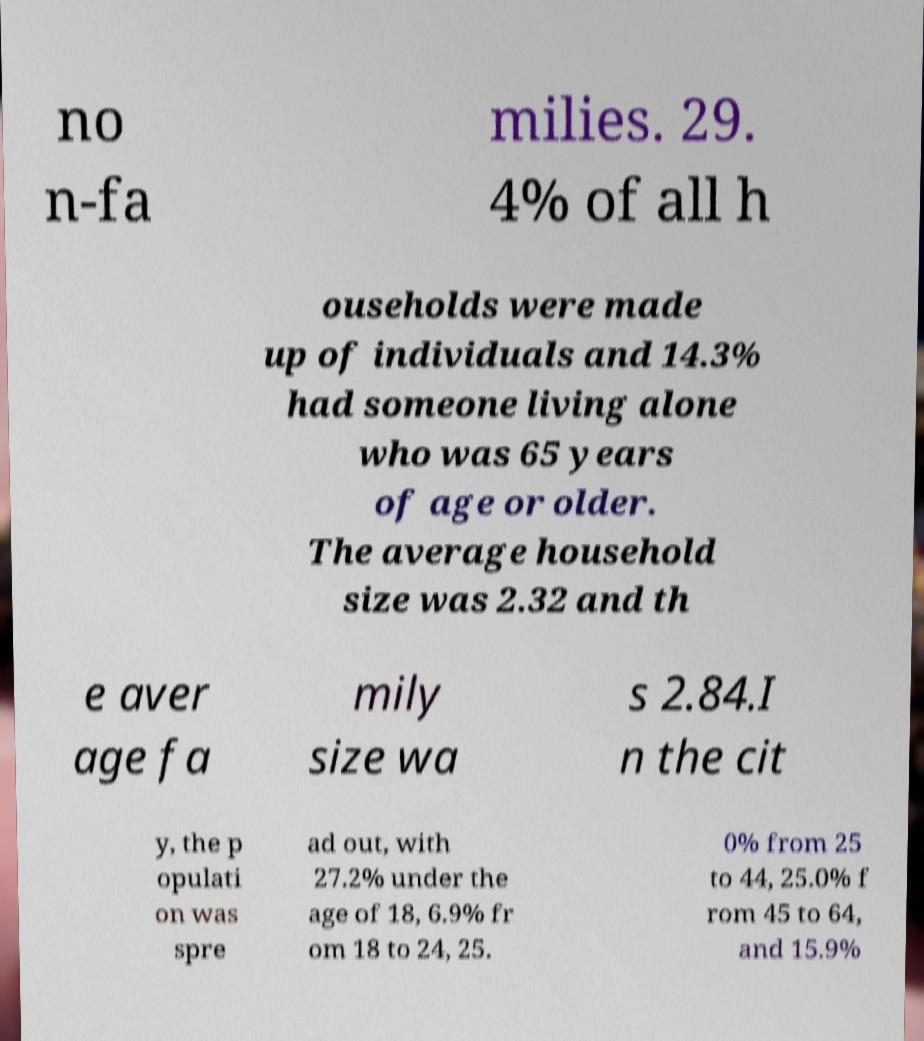Can you read and provide the text displayed in the image?This photo seems to have some interesting text. Can you extract and type it out for me? no n-fa milies. 29. 4% of all h ouseholds were made up of individuals and 14.3% had someone living alone who was 65 years of age or older. The average household size was 2.32 and th e aver age fa mily size wa s 2.84.I n the cit y, the p opulati on was spre ad out, with 27.2% under the age of 18, 6.9% fr om 18 to 24, 25. 0% from 25 to 44, 25.0% f rom 45 to 64, and 15.9% 